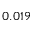<formula> <loc_0><loc_0><loc_500><loc_500>0 . 0 1 9</formula> 